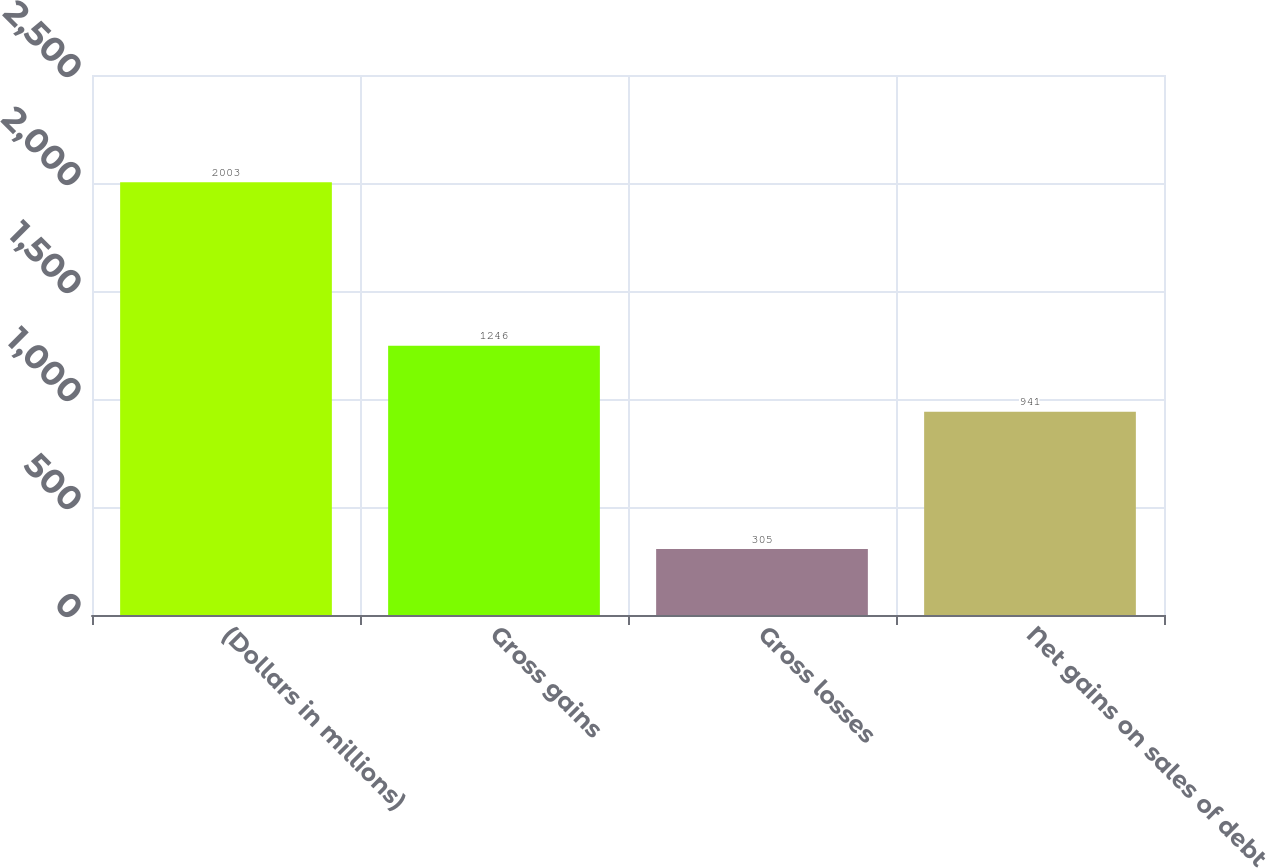Convert chart. <chart><loc_0><loc_0><loc_500><loc_500><bar_chart><fcel>(Dollars in millions)<fcel>Gross gains<fcel>Gross losses<fcel>Net gains on sales of debt<nl><fcel>2003<fcel>1246<fcel>305<fcel>941<nl></chart> 